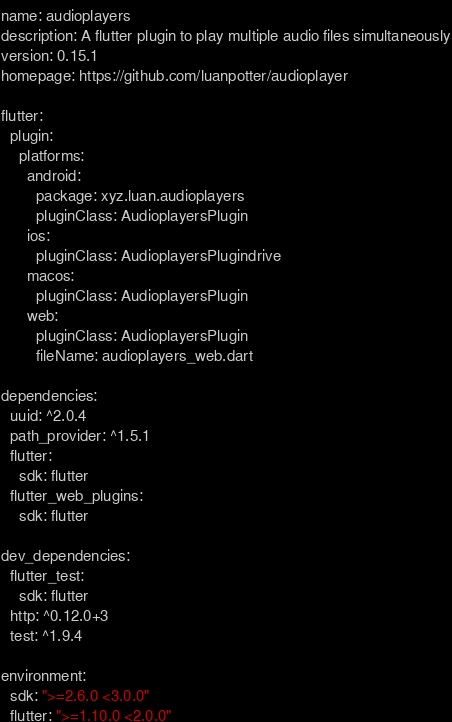Convert code to text. <code><loc_0><loc_0><loc_500><loc_500><_YAML_>name: audioplayers
description: A flutter plugin to play multiple audio files simultaneously
version: 0.15.1
homepage: https://github.com/luanpotter/audioplayer

flutter:
  plugin:
    platforms:
      android:
        package: xyz.luan.audioplayers
        pluginClass: AudioplayersPlugin
      ios:
        pluginClass: AudioplayersPlugindrive
      macos:
        pluginClass: AudioplayersPlugin
      web:
        pluginClass: AudioplayersPlugin
        fileName: audioplayers_web.dart

dependencies:
  uuid: ^2.0.4
  path_provider: ^1.5.1
  flutter:
    sdk: flutter
  flutter_web_plugins:
    sdk: flutter

dev_dependencies:
  flutter_test:
    sdk: flutter
  http: ^0.12.0+3
  test: ^1.9.4

environment:
  sdk: ">=2.6.0 <3.0.0"
  flutter: ">=1.10.0 <2.0.0"

</code> 